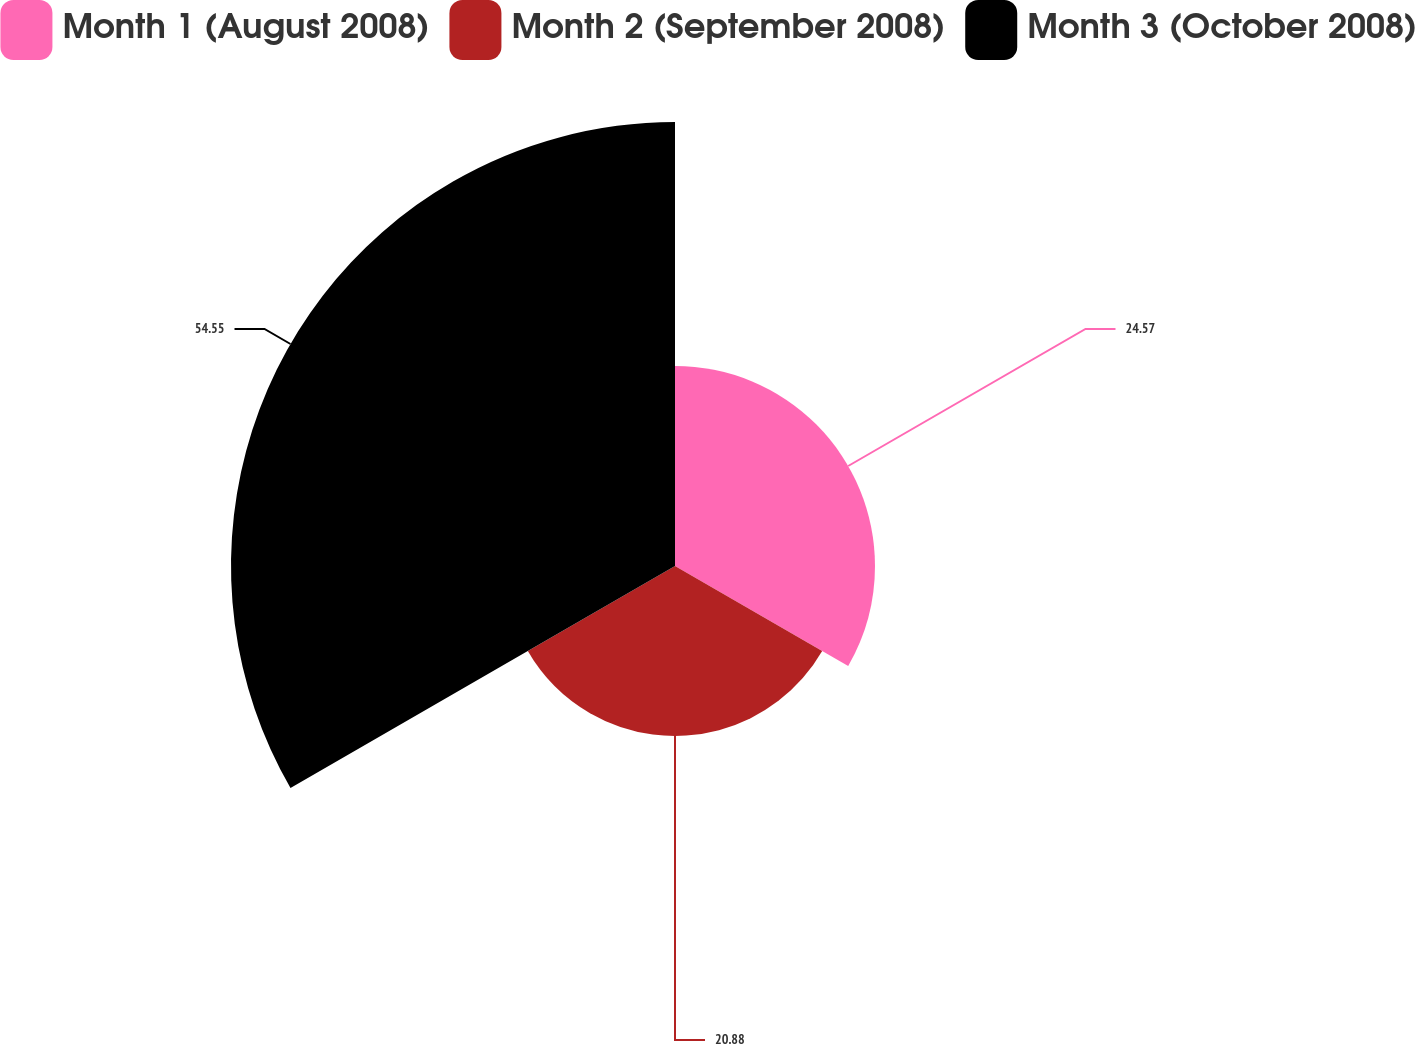Convert chart. <chart><loc_0><loc_0><loc_500><loc_500><pie_chart><fcel>Month 1 (August 2008)<fcel>Month 2 (September 2008)<fcel>Month 3 (October 2008)<nl><fcel>24.57%<fcel>20.88%<fcel>54.55%<nl></chart> 